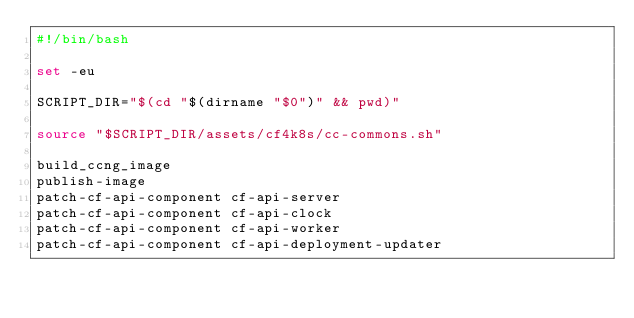Convert code to text. <code><loc_0><loc_0><loc_500><loc_500><_Bash_>#!/bin/bash

set -eu

SCRIPT_DIR="$(cd "$(dirname "$0")" && pwd)"

source "$SCRIPT_DIR/assets/cf4k8s/cc-commons.sh"

build_ccng_image
publish-image
patch-cf-api-component cf-api-server
patch-cf-api-component cf-api-clock
patch-cf-api-component cf-api-worker
patch-cf-api-component cf-api-deployment-updater
</code> 